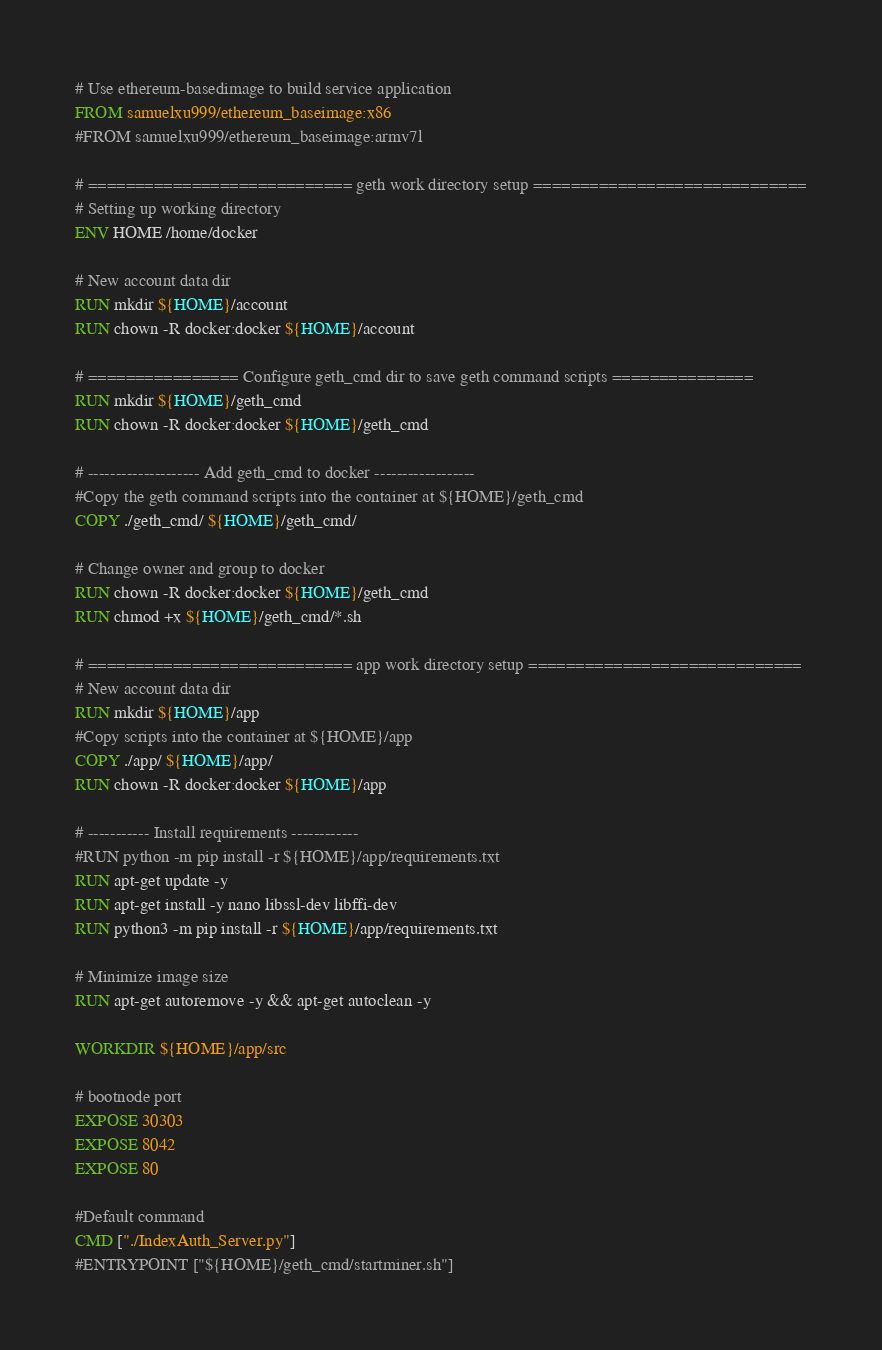Convert code to text. <code><loc_0><loc_0><loc_500><loc_500><_Dockerfile_># Use ethereum-basedimage to build service application
FROM samuelxu999/ethereum_baseimage:x86
#FROM samuelxu999/ethereum_baseimage:armv7l

# ============================ geth work directory setup =============================
# Setting up working directory
ENV HOME /home/docker

# New account data dir 
RUN mkdir ${HOME}/account
RUN chown -R docker:docker ${HOME}/account

# ================ Configure geth_cmd dir to save geth command scripts ===============
RUN mkdir ${HOME}/geth_cmd
RUN chown -R docker:docker ${HOME}/geth_cmd

# -------------------- Add geth_cmd to docker ------------------
#Copy the geth command scripts into the container at ${HOME}/geth_cmd
COPY ./geth_cmd/ ${HOME}/geth_cmd/

# Change owner and group to docker
RUN chown -R docker:docker ${HOME}/geth_cmd
RUN chmod +x ${HOME}/geth_cmd/*.sh

# ============================ app work directory setup =============================
# New account data dir 
RUN mkdir ${HOME}/app
#Copy scripts into the container at ${HOME}/app
COPY ./app/ ${HOME}/app/
RUN chown -R docker:docker ${HOME}/app

# ----------- Install requirements ------------
#RUN python -m pip install -r ${HOME}/app/requirements.txt
RUN apt-get update -y
RUN apt-get install -y nano libssl-dev libffi-dev
RUN python3 -m pip install -r ${HOME}/app/requirements.txt

# Minimize image size 
RUN apt-get autoremove -y && apt-get autoclean -y

WORKDIR ${HOME}/app/src

# bootnode port
EXPOSE 30303
EXPOSE 8042
EXPOSE 80

#Default command
CMD ["./IndexAuth_Server.py"]
#ENTRYPOINT ["${HOME}/geth_cmd/startminer.sh"]
</code> 